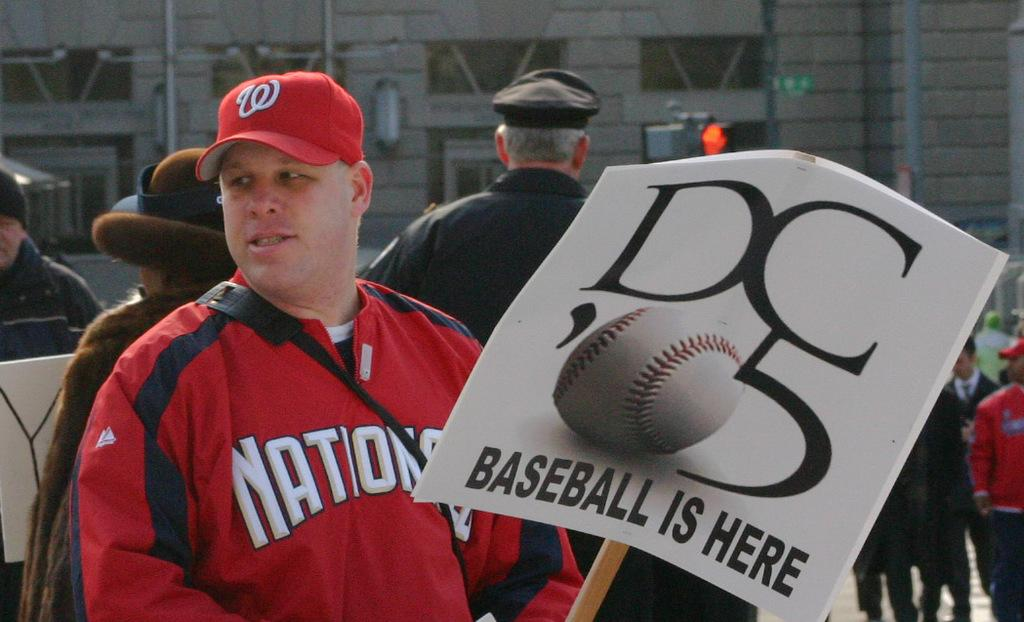<image>
Provide a brief description of the given image. A man in a Nationals shirt holding a sign aht says Baseball is here. 